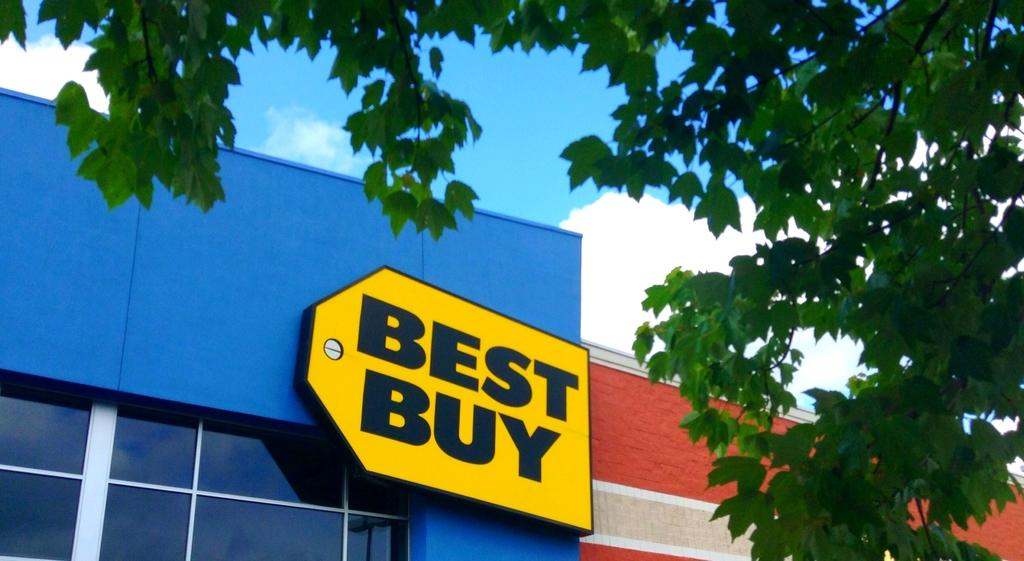What type of natural element can be seen in the image? There is a tree in the image. How would you describe the sky in the image? The sky is blue and cloudy in the image. How many buildings are visible in the image? There are two buildings in the image. What is on top of one of the buildings? There is an advertising board on the top of one of the buildings. Can you see a boat in the image? No, there is no boat present in the image. Is anyone getting a haircut in the image? No, there is no indication of a haircut or anyone getting a haircut in the image. 